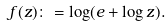<formula> <loc_0><loc_0><loc_500><loc_500>f ( z ) \colon = \log ( e + \log z ) .</formula> 